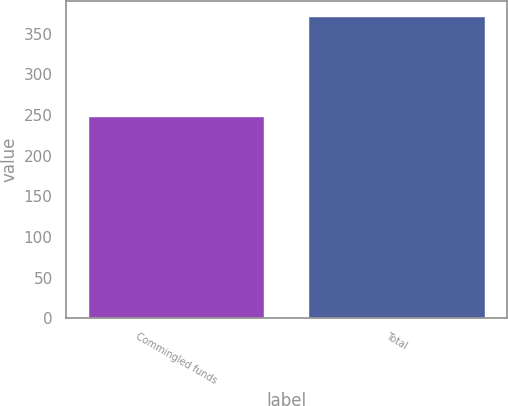Convert chart. <chart><loc_0><loc_0><loc_500><loc_500><bar_chart><fcel>Commingled funds<fcel>Total<nl><fcel>248.6<fcel>371.9<nl></chart> 